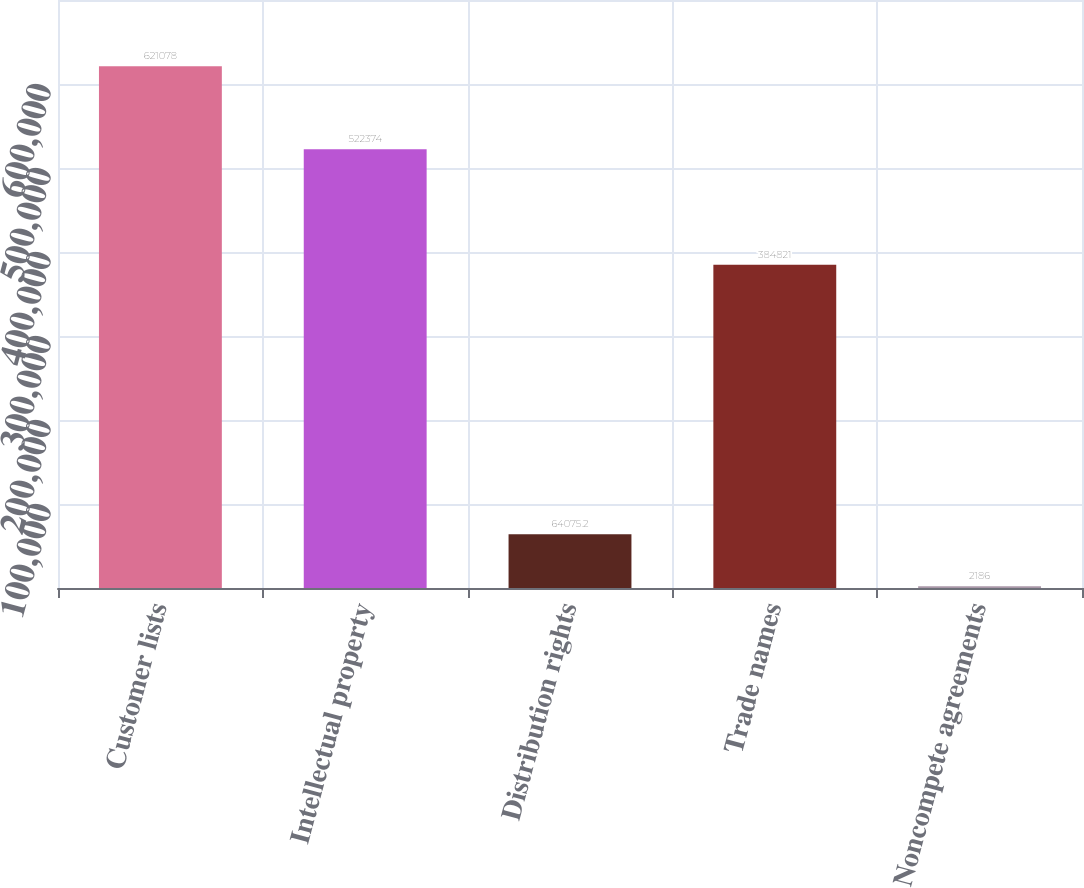<chart> <loc_0><loc_0><loc_500><loc_500><bar_chart><fcel>Customer lists<fcel>Intellectual property<fcel>Distribution rights<fcel>Trade names<fcel>Noncompete agreements<nl><fcel>621078<fcel>522374<fcel>64075.2<fcel>384821<fcel>2186<nl></chart> 